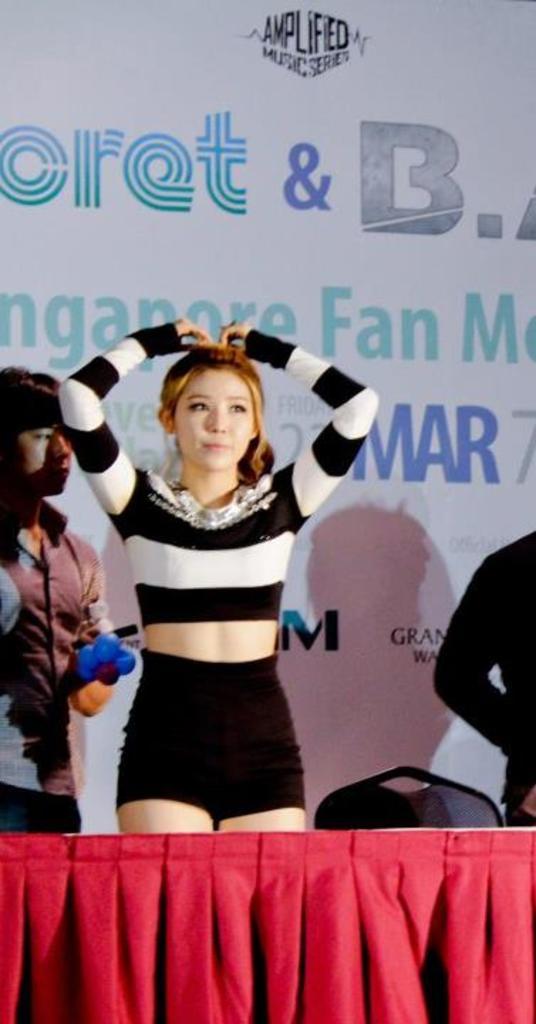What letter can be seen above the woman?
Offer a very short reply. T. 